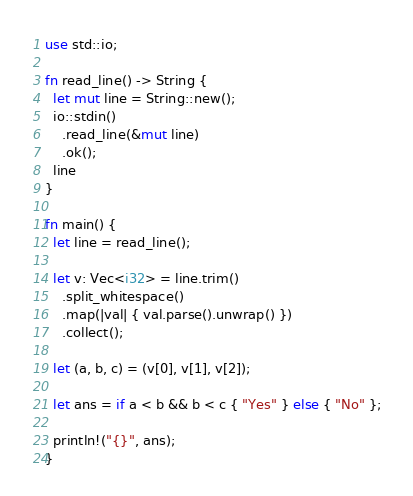Convert code to text. <code><loc_0><loc_0><loc_500><loc_500><_Rust_>use std::io;

fn read_line() -> String {
  let mut line = String::new();
  io::stdin()
    .read_line(&mut line)
    .ok();
  line
}

fn main() {
  let line = read_line();

  let v: Vec<i32> = line.trim()
    .split_whitespace()
    .map(|val| { val.parse().unwrap() })
    .collect();
  
  let (a, b, c) = (v[0], v[1], v[2]);

  let ans = if a < b && b < c { "Yes" } else { "No" };

  println!("{}", ans);
}

</code> 